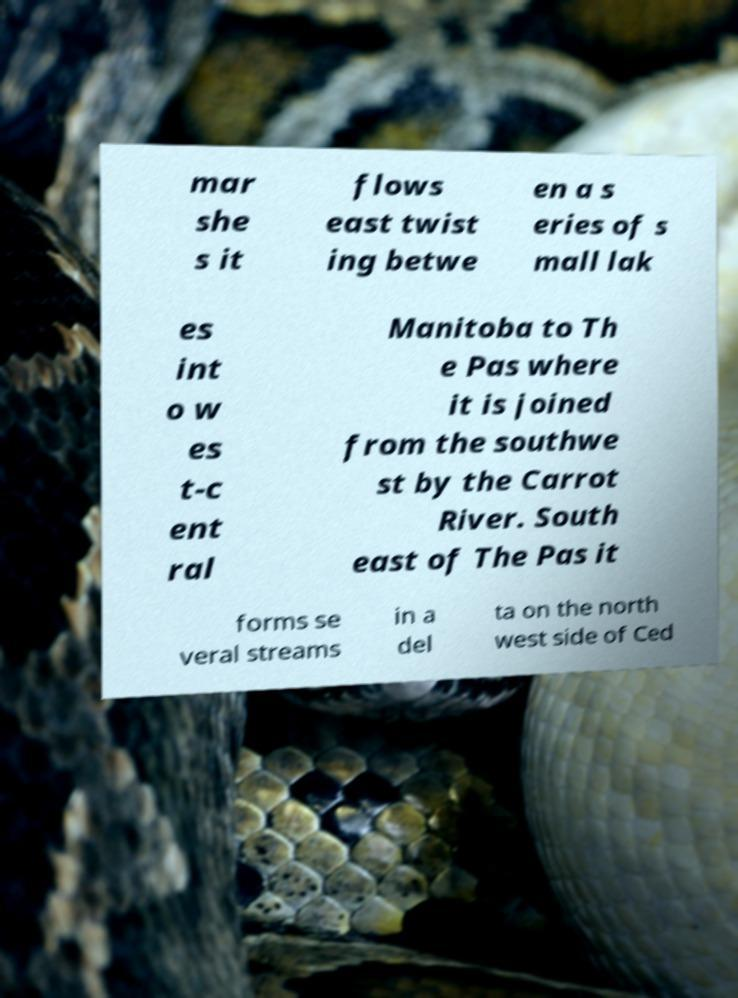Please identify and transcribe the text found in this image. mar she s it flows east twist ing betwe en a s eries of s mall lak es int o w es t-c ent ral Manitoba to Th e Pas where it is joined from the southwe st by the Carrot River. South east of The Pas it forms se veral streams in a del ta on the north west side of Ced 